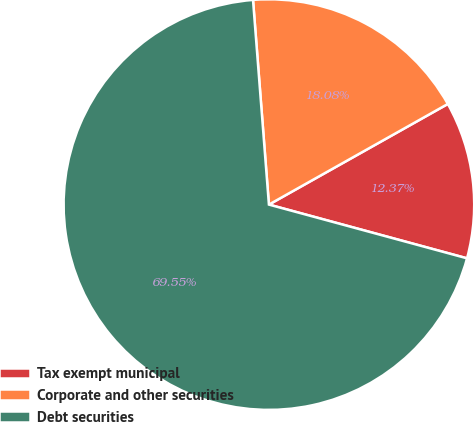Convert chart. <chart><loc_0><loc_0><loc_500><loc_500><pie_chart><fcel>Tax exempt municipal<fcel>Corporate and other securities<fcel>Debt securities<nl><fcel>12.37%<fcel>18.08%<fcel>69.55%<nl></chart> 